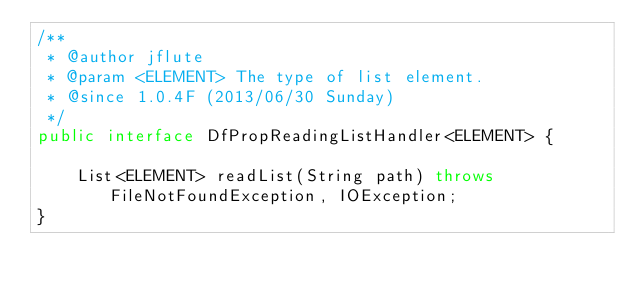<code> <loc_0><loc_0><loc_500><loc_500><_Java_>/**
 * @author jflute
 * @param <ELEMENT> The type of list element.
 * @since 1.0.4F (2013/06/30 Sunday)
 */
public interface DfPropReadingListHandler<ELEMENT> {

    List<ELEMENT> readList(String path) throws FileNotFoundException, IOException;
}
</code> 